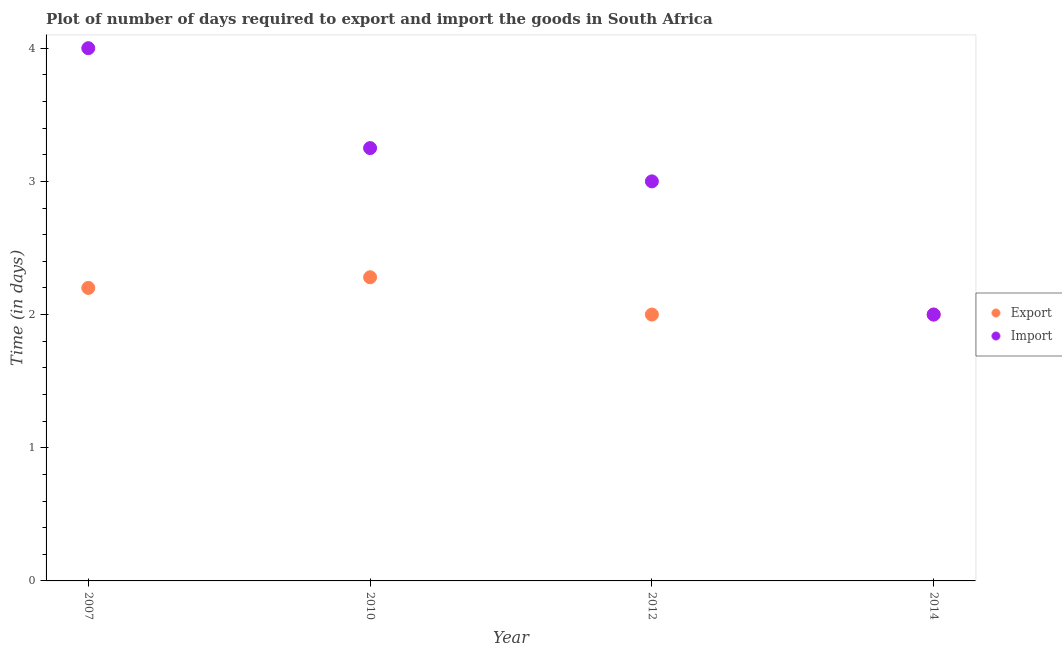Is the number of dotlines equal to the number of legend labels?
Ensure brevity in your answer.  Yes. What is the time required to export in 2010?
Give a very brief answer. 2.28. Across all years, what is the maximum time required to export?
Make the answer very short. 2.28. Across all years, what is the minimum time required to import?
Your answer should be very brief. 2. In which year was the time required to export maximum?
Offer a very short reply. 2010. In which year was the time required to export minimum?
Your answer should be very brief. 2012. What is the total time required to export in the graph?
Offer a terse response. 8.48. What is the difference between the time required to import in 2007 and the time required to export in 2012?
Offer a terse response. 2. What is the average time required to import per year?
Your answer should be compact. 3.06. In the year 2010, what is the difference between the time required to export and time required to import?
Offer a very short reply. -0.97. In how many years, is the time required to export greater than 2.6 days?
Offer a terse response. 0. What is the ratio of the time required to import in 2007 to that in 2010?
Provide a short and direct response. 1.23. Is the difference between the time required to import in 2007 and 2012 greater than the difference between the time required to export in 2007 and 2012?
Keep it short and to the point. Yes. What is the difference between the highest and the second highest time required to export?
Give a very brief answer. 0.08. What is the difference between the highest and the lowest time required to import?
Provide a short and direct response. 2. Is the sum of the time required to export in 2007 and 2014 greater than the maximum time required to import across all years?
Your answer should be very brief. Yes. Is the time required to export strictly greater than the time required to import over the years?
Make the answer very short. No. Is the time required to export strictly less than the time required to import over the years?
Give a very brief answer. No. How many legend labels are there?
Your answer should be compact. 2. How are the legend labels stacked?
Offer a terse response. Vertical. What is the title of the graph?
Offer a very short reply. Plot of number of days required to export and import the goods in South Africa. Does "Private credit bureau" appear as one of the legend labels in the graph?
Make the answer very short. No. What is the label or title of the Y-axis?
Give a very brief answer. Time (in days). What is the Time (in days) of Export in 2007?
Make the answer very short. 2.2. What is the Time (in days) of Import in 2007?
Provide a short and direct response. 4. What is the Time (in days) of Export in 2010?
Your answer should be compact. 2.28. What is the Time (in days) in Export in 2014?
Keep it short and to the point. 2. What is the Time (in days) in Import in 2014?
Your response must be concise. 2. Across all years, what is the maximum Time (in days) in Export?
Keep it short and to the point. 2.28. What is the total Time (in days) of Export in the graph?
Offer a very short reply. 8.48. What is the total Time (in days) in Import in the graph?
Your answer should be very brief. 12.25. What is the difference between the Time (in days) of Export in 2007 and that in 2010?
Give a very brief answer. -0.08. What is the difference between the Time (in days) of Import in 2007 and that in 2010?
Your answer should be very brief. 0.75. What is the difference between the Time (in days) of Export in 2007 and that in 2012?
Offer a terse response. 0.2. What is the difference between the Time (in days) in Export in 2010 and that in 2012?
Your answer should be compact. 0.28. What is the difference between the Time (in days) in Import in 2010 and that in 2012?
Keep it short and to the point. 0.25. What is the difference between the Time (in days) in Export in 2010 and that in 2014?
Ensure brevity in your answer.  0.28. What is the difference between the Time (in days) of Export in 2007 and the Time (in days) of Import in 2010?
Your answer should be very brief. -1.05. What is the difference between the Time (in days) in Export in 2007 and the Time (in days) in Import in 2014?
Give a very brief answer. 0.2. What is the difference between the Time (in days) of Export in 2010 and the Time (in days) of Import in 2012?
Provide a short and direct response. -0.72. What is the difference between the Time (in days) in Export in 2010 and the Time (in days) in Import in 2014?
Provide a short and direct response. 0.28. What is the average Time (in days) of Export per year?
Provide a succinct answer. 2.12. What is the average Time (in days) in Import per year?
Your answer should be very brief. 3.06. In the year 2007, what is the difference between the Time (in days) in Export and Time (in days) in Import?
Keep it short and to the point. -1.8. In the year 2010, what is the difference between the Time (in days) in Export and Time (in days) in Import?
Ensure brevity in your answer.  -0.97. In the year 2012, what is the difference between the Time (in days) in Export and Time (in days) in Import?
Your response must be concise. -1. In the year 2014, what is the difference between the Time (in days) in Export and Time (in days) in Import?
Your response must be concise. 0. What is the ratio of the Time (in days) in Export in 2007 to that in 2010?
Ensure brevity in your answer.  0.96. What is the ratio of the Time (in days) of Import in 2007 to that in 2010?
Keep it short and to the point. 1.23. What is the ratio of the Time (in days) in Export in 2007 to that in 2012?
Your answer should be compact. 1.1. What is the ratio of the Time (in days) in Export in 2007 to that in 2014?
Make the answer very short. 1.1. What is the ratio of the Time (in days) of Import in 2007 to that in 2014?
Ensure brevity in your answer.  2. What is the ratio of the Time (in days) in Export in 2010 to that in 2012?
Give a very brief answer. 1.14. What is the ratio of the Time (in days) of Import in 2010 to that in 2012?
Your response must be concise. 1.08. What is the ratio of the Time (in days) in Export in 2010 to that in 2014?
Make the answer very short. 1.14. What is the ratio of the Time (in days) in Import in 2010 to that in 2014?
Make the answer very short. 1.62. What is the ratio of the Time (in days) in Import in 2012 to that in 2014?
Your answer should be compact. 1.5. What is the difference between the highest and the lowest Time (in days) of Export?
Your response must be concise. 0.28. What is the difference between the highest and the lowest Time (in days) in Import?
Provide a succinct answer. 2. 